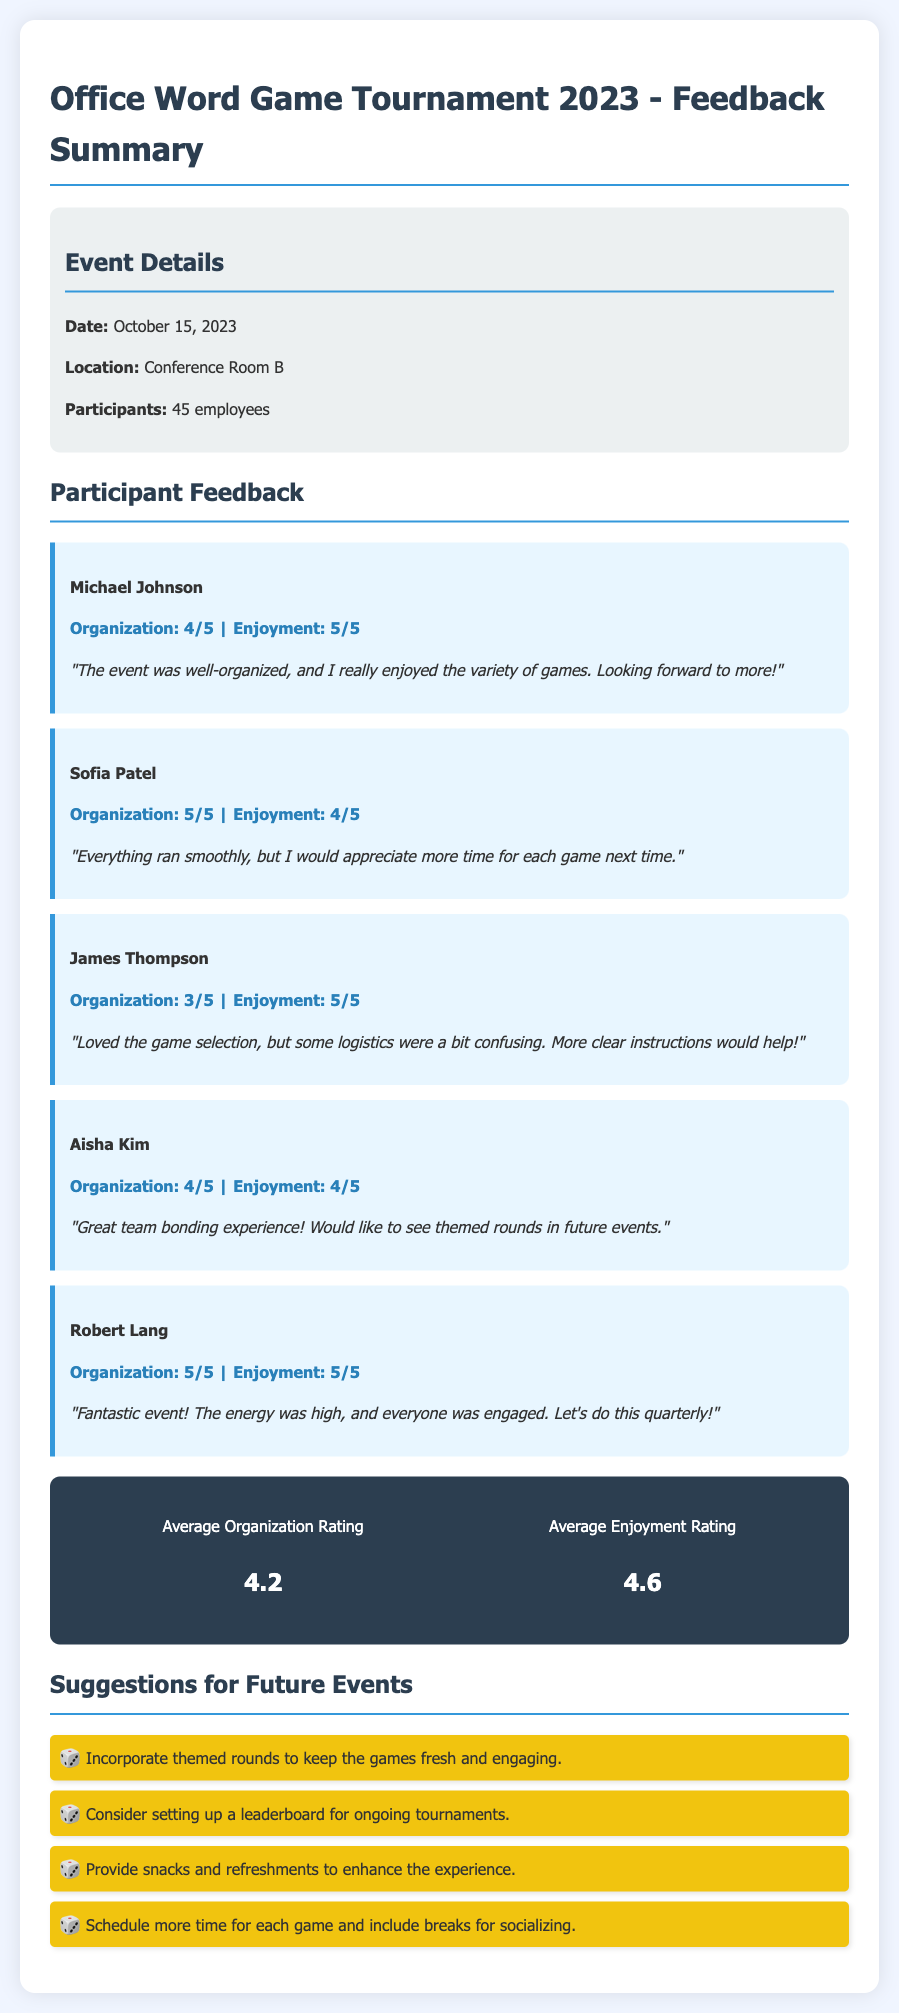What date did the tournament occur? The tournament date is explicitly mentioned in the document under Event Details.
Answer: October 15, 2023 What was the average organization rating? The average organization rating is calculated based on participant ratings found in the feedback section.
Answer: 4.2 How many participants were there? The total number of participants is provided in the Event Details section of the document.
Answer: 45 employees What did Robert Lang say about the event? Participant comments are summarized in the feedback section, highlighting specific praises or suggestions.
Answer: "Fantastic event! The energy was high, and everyone was engaged. Let's do this quarterly!" Which participant suggested incorporating themed rounds? The feedback section contains individual comments, indicating which participant made specific suggestions.
Answer: Aisha Kim What is the average enjoyment rating? The average enjoyment rating is computed from the feedback ratings in the document.
Answer: 4.6 What was a common suggestion for future events? Suggestions are listed at the end of the document and provide insights into participant desires for future tournaments.
Answer: Incorporate themed rounds to keep the games fresh and engaging What location hosted the tournament? The location is specified in the Event Details section of the document.
Answer: Conference Room B 